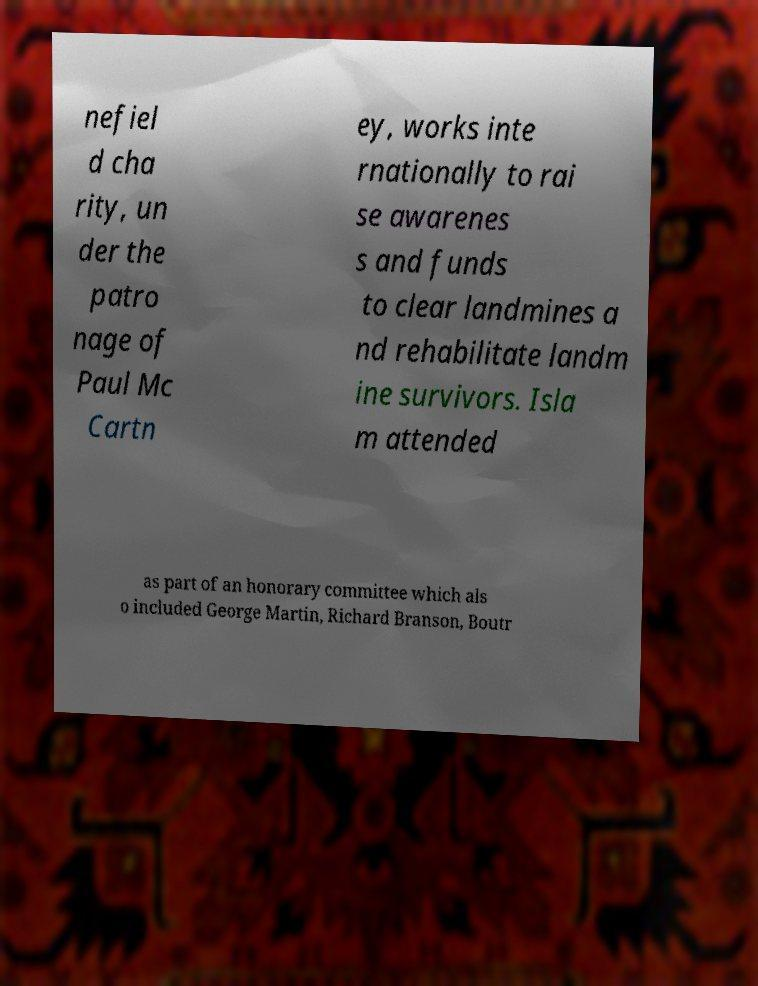What messages or text are displayed in this image? I need them in a readable, typed format. nefiel d cha rity, un der the patro nage of Paul Mc Cartn ey, works inte rnationally to rai se awarenes s and funds to clear landmines a nd rehabilitate landm ine survivors. Isla m attended as part of an honorary committee which als o included George Martin, Richard Branson, Boutr 